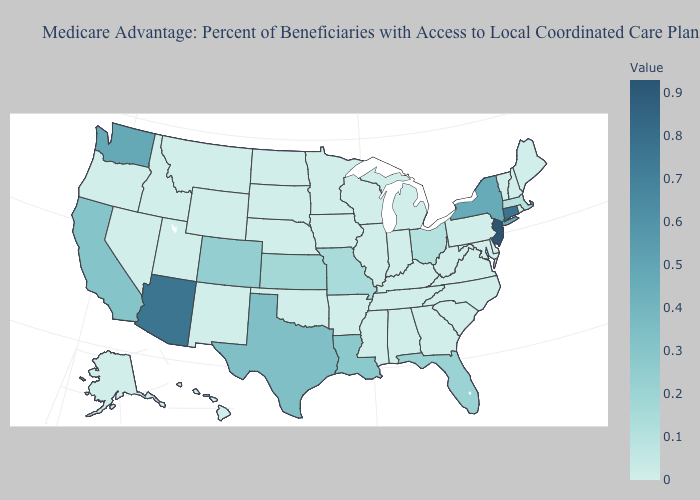Which states have the lowest value in the West?
Keep it brief. Alaska, Hawaii, Idaho, Montana, New Mexico, Nevada, Oregon, Utah, Wyoming. Among the states that border New Jersey , which have the lowest value?
Quick response, please. Delaware, Pennsylvania. Does Ohio have the lowest value in the USA?
Quick response, please. No. Does Arizona have the lowest value in the USA?
Keep it brief. No. Which states hav the highest value in the MidWest?
Be succinct. Kansas. 